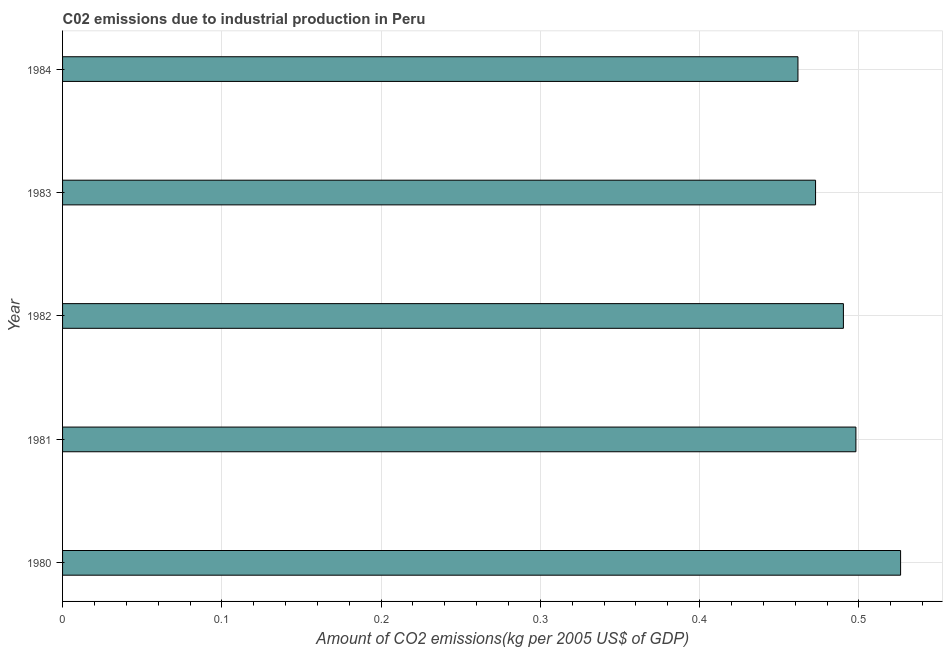What is the title of the graph?
Your answer should be compact. C02 emissions due to industrial production in Peru. What is the label or title of the X-axis?
Provide a short and direct response. Amount of CO2 emissions(kg per 2005 US$ of GDP). What is the amount of co2 emissions in 1983?
Provide a short and direct response. 0.47. Across all years, what is the maximum amount of co2 emissions?
Offer a terse response. 0.53. Across all years, what is the minimum amount of co2 emissions?
Your answer should be very brief. 0.46. What is the sum of the amount of co2 emissions?
Your response must be concise. 2.45. What is the difference between the amount of co2 emissions in 1980 and 1981?
Provide a succinct answer. 0.03. What is the average amount of co2 emissions per year?
Ensure brevity in your answer.  0.49. What is the median amount of co2 emissions?
Keep it short and to the point. 0.49. In how many years, is the amount of co2 emissions greater than 0.14 kg per 2005 US$ of GDP?
Your response must be concise. 5. Do a majority of the years between 1983 and 1981 (inclusive) have amount of co2 emissions greater than 0.22 kg per 2005 US$ of GDP?
Your answer should be compact. Yes. What is the difference between the highest and the second highest amount of co2 emissions?
Ensure brevity in your answer.  0.03. Is the sum of the amount of co2 emissions in 1981 and 1982 greater than the maximum amount of co2 emissions across all years?
Offer a very short reply. Yes. How many bars are there?
Your response must be concise. 5. Are all the bars in the graph horizontal?
Your answer should be compact. Yes. How many years are there in the graph?
Offer a terse response. 5. What is the difference between two consecutive major ticks on the X-axis?
Your response must be concise. 0.1. Are the values on the major ticks of X-axis written in scientific E-notation?
Offer a very short reply. No. What is the Amount of CO2 emissions(kg per 2005 US$ of GDP) of 1980?
Offer a terse response. 0.53. What is the Amount of CO2 emissions(kg per 2005 US$ of GDP) in 1981?
Keep it short and to the point. 0.5. What is the Amount of CO2 emissions(kg per 2005 US$ of GDP) in 1982?
Offer a terse response. 0.49. What is the Amount of CO2 emissions(kg per 2005 US$ of GDP) of 1983?
Provide a short and direct response. 0.47. What is the Amount of CO2 emissions(kg per 2005 US$ of GDP) of 1984?
Offer a very short reply. 0.46. What is the difference between the Amount of CO2 emissions(kg per 2005 US$ of GDP) in 1980 and 1981?
Offer a terse response. 0.03. What is the difference between the Amount of CO2 emissions(kg per 2005 US$ of GDP) in 1980 and 1982?
Offer a very short reply. 0.04. What is the difference between the Amount of CO2 emissions(kg per 2005 US$ of GDP) in 1980 and 1983?
Provide a succinct answer. 0.05. What is the difference between the Amount of CO2 emissions(kg per 2005 US$ of GDP) in 1980 and 1984?
Offer a very short reply. 0.06. What is the difference between the Amount of CO2 emissions(kg per 2005 US$ of GDP) in 1981 and 1982?
Keep it short and to the point. 0.01. What is the difference between the Amount of CO2 emissions(kg per 2005 US$ of GDP) in 1981 and 1983?
Offer a terse response. 0.03. What is the difference between the Amount of CO2 emissions(kg per 2005 US$ of GDP) in 1981 and 1984?
Give a very brief answer. 0.04. What is the difference between the Amount of CO2 emissions(kg per 2005 US$ of GDP) in 1982 and 1983?
Ensure brevity in your answer.  0.02. What is the difference between the Amount of CO2 emissions(kg per 2005 US$ of GDP) in 1982 and 1984?
Give a very brief answer. 0.03. What is the difference between the Amount of CO2 emissions(kg per 2005 US$ of GDP) in 1983 and 1984?
Your answer should be compact. 0.01. What is the ratio of the Amount of CO2 emissions(kg per 2005 US$ of GDP) in 1980 to that in 1981?
Give a very brief answer. 1.06. What is the ratio of the Amount of CO2 emissions(kg per 2005 US$ of GDP) in 1980 to that in 1982?
Give a very brief answer. 1.07. What is the ratio of the Amount of CO2 emissions(kg per 2005 US$ of GDP) in 1980 to that in 1983?
Provide a short and direct response. 1.11. What is the ratio of the Amount of CO2 emissions(kg per 2005 US$ of GDP) in 1980 to that in 1984?
Ensure brevity in your answer.  1.14. What is the ratio of the Amount of CO2 emissions(kg per 2005 US$ of GDP) in 1981 to that in 1983?
Your answer should be compact. 1.05. What is the ratio of the Amount of CO2 emissions(kg per 2005 US$ of GDP) in 1981 to that in 1984?
Your response must be concise. 1.08. What is the ratio of the Amount of CO2 emissions(kg per 2005 US$ of GDP) in 1982 to that in 1983?
Your response must be concise. 1.04. What is the ratio of the Amount of CO2 emissions(kg per 2005 US$ of GDP) in 1982 to that in 1984?
Offer a very short reply. 1.06. What is the ratio of the Amount of CO2 emissions(kg per 2005 US$ of GDP) in 1983 to that in 1984?
Offer a terse response. 1.02. 